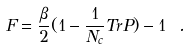<formula> <loc_0><loc_0><loc_500><loc_500>F = { \frac { \beta } { 2 } } ( 1 - { \frac { 1 } { N _ { c } } } T r P ) - 1 \ .</formula> 